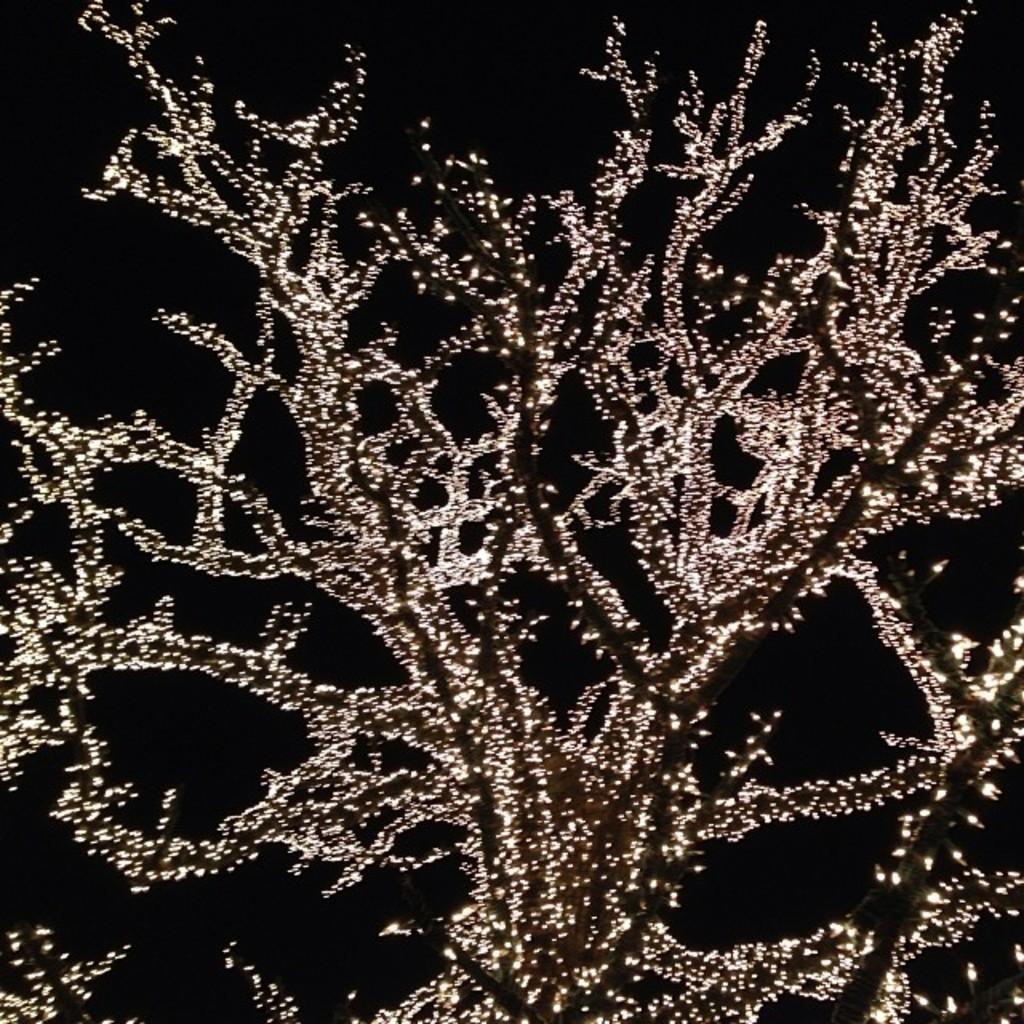What is the main subject of the image? The main subject of the image is a tree. What feature does the tree have in the image? The tree has decorative lights in the image. What is the color of the background in the image? The background of the image is black. How many fingers can be seen on the actor in the image? There is no actor present in the image, so there are no fingers to count. 